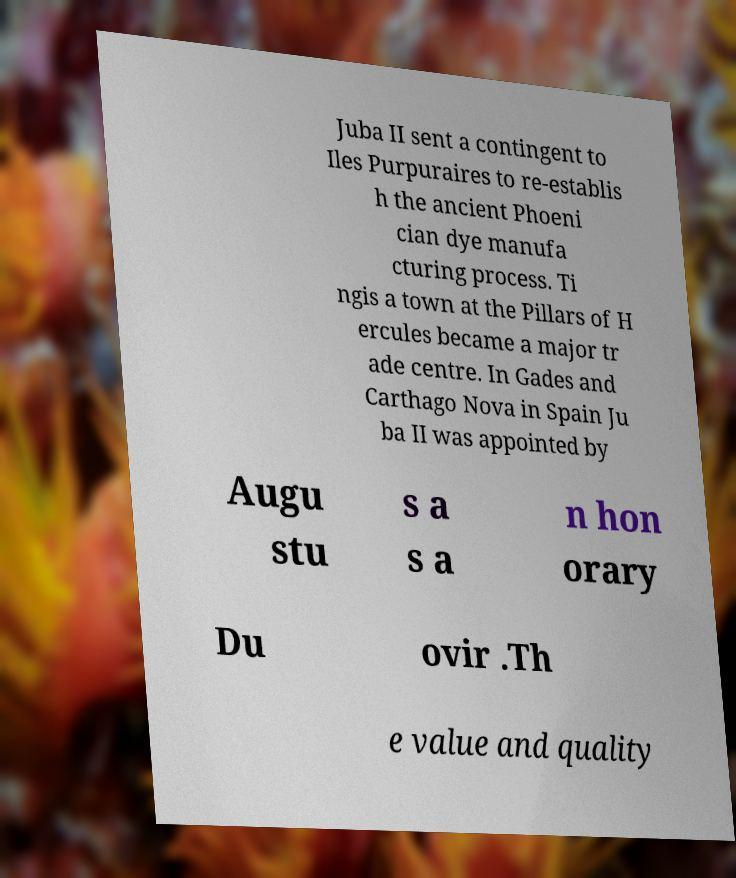Could you assist in decoding the text presented in this image and type it out clearly? Juba II sent a contingent to Iles Purpuraires to re-establis h the ancient Phoeni cian dye manufa cturing process. Ti ngis a town at the Pillars of H ercules became a major tr ade centre. In Gades and Carthago Nova in Spain Ju ba II was appointed by Augu stu s a s a n hon orary Du ovir .Th e value and quality 